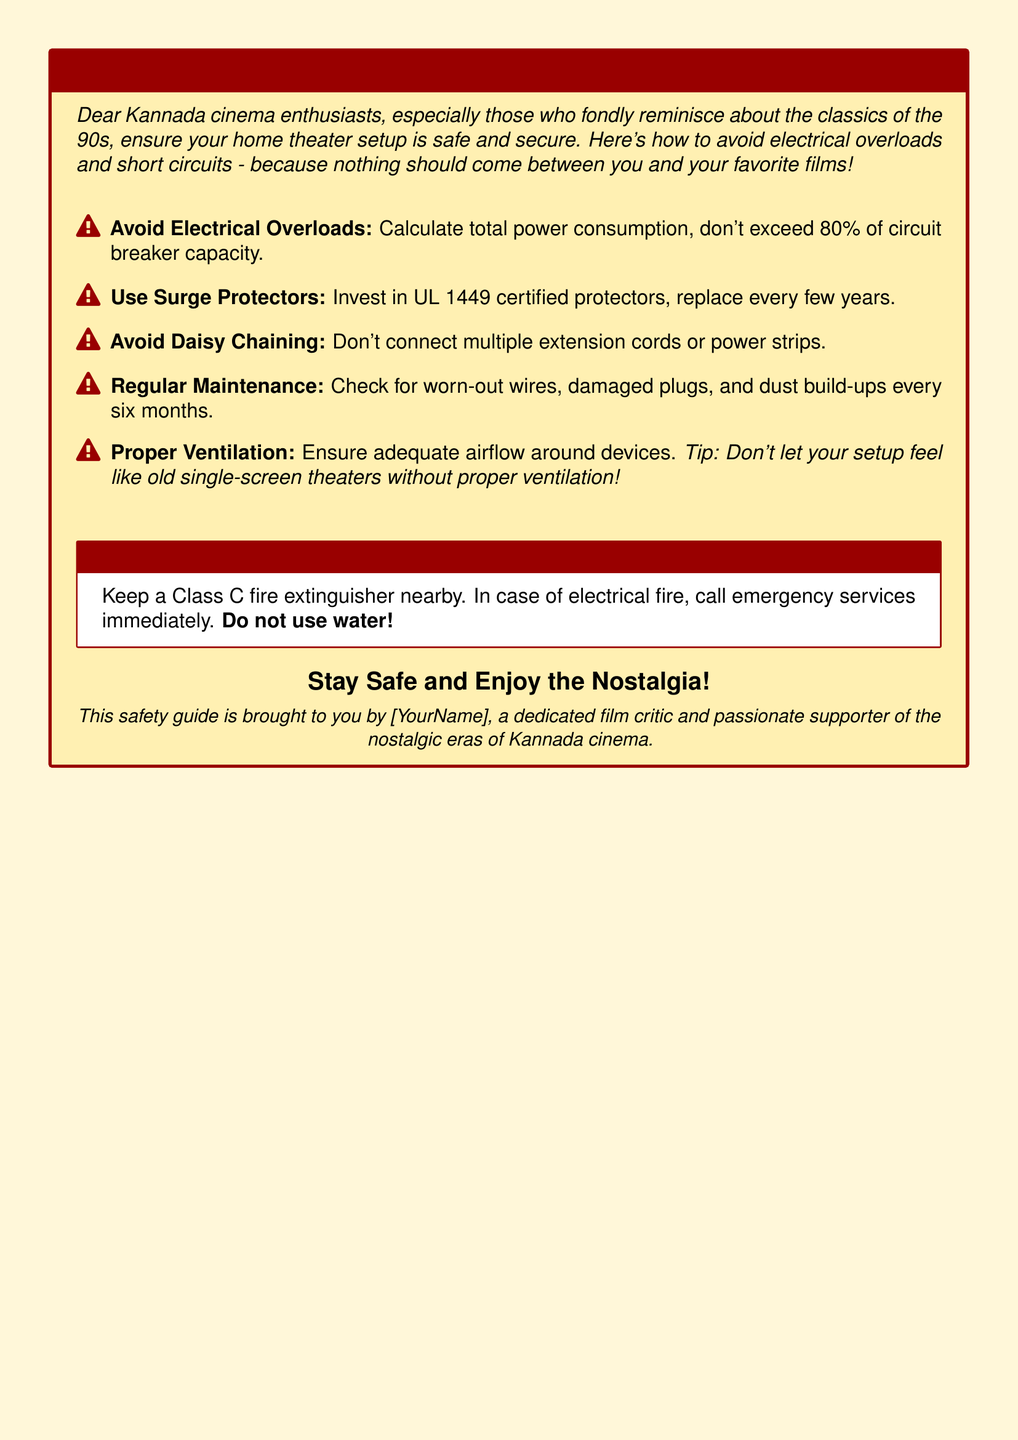What is the main title of the warning label? The main title is prominently displayed at the top of the document, emphasizing the importance of preventing fire hazards in home theater setups.
Answer: WARNING: Prevent Fire Hazards in Your Home Theater Setup! What is the recommended maximum percentage for circuit breaker capacity? The document advises not to exceed a certain percentage of the circuit breaker capacity to prevent overloads.
Answer: 80% Which type of fire extinguisher is suggested for emergencies? The document specifies the type of fire extinguisher that should be kept nearby for electrical fire emergencies.
Answer: Class C How often should wires and plugs be checked for wear? The document states the frequency for checking worn-out wires and damaged plugs to ensure safety.
Answer: Every six months What is a tip for proper ventilation mentioned in the document? The document includes a tip to compare the setup’s airflow to a nostalgic reference from the past, enhancing understanding.
Answer: Don't let your setup feel like old single-screen theaters without proper ventilation! What should you do in case of an electrical fire? The document instructs specific actions to take in the event of an electrical fire, which is crucial for safety.
Answer: Call emergency services immediately What should be used instead of water during a fire? The document warns against using a common substance during an electrical fire and clarifies the safety measures.
Answer: Do not use water! What should be replaced every few years according to the document? The document mentions a specific item that needs to be replaced periodically to ensure continued protection against surges.
Answer: Surge protectors What color is used for the frame in the warning box? The document describes a color used for the frame of the warning box that aligns with the overall theme.
Answer: Nostalgic red What is the overall background color of the page? The document specifies the background color of the page, which aims to create a warning effect while being visually appealing.
Answer: Warning yellow 